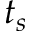<formula> <loc_0><loc_0><loc_500><loc_500>t _ { s }</formula> 